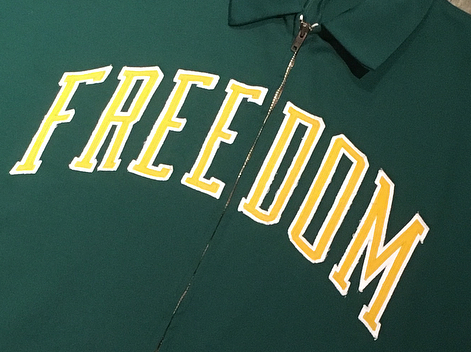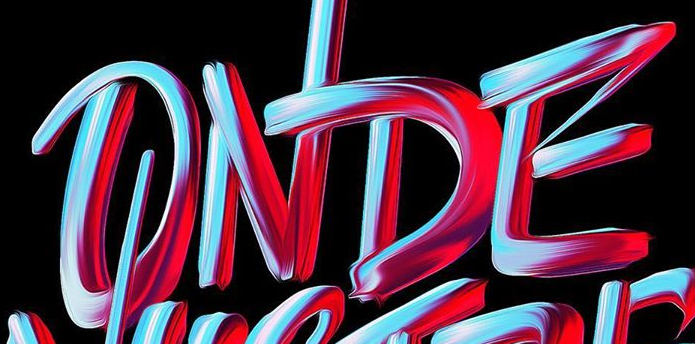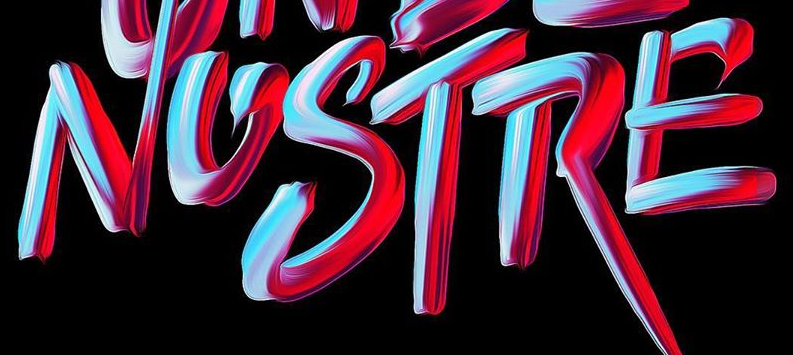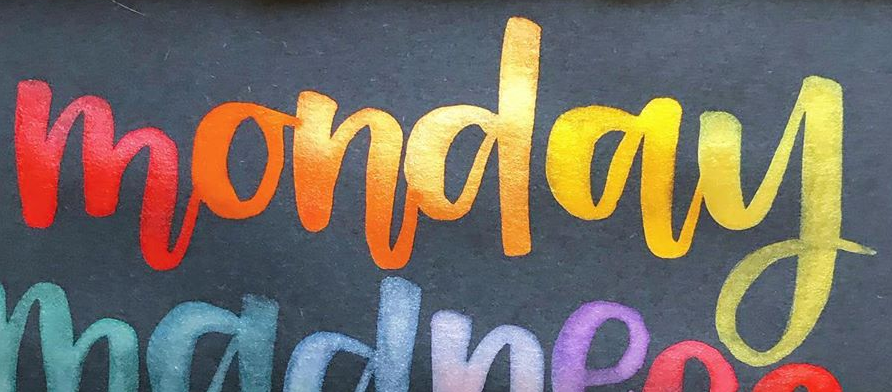What words are shown in these images in order, separated by a semicolon? FREEDOM; ONDE; NOSTRE; monday 